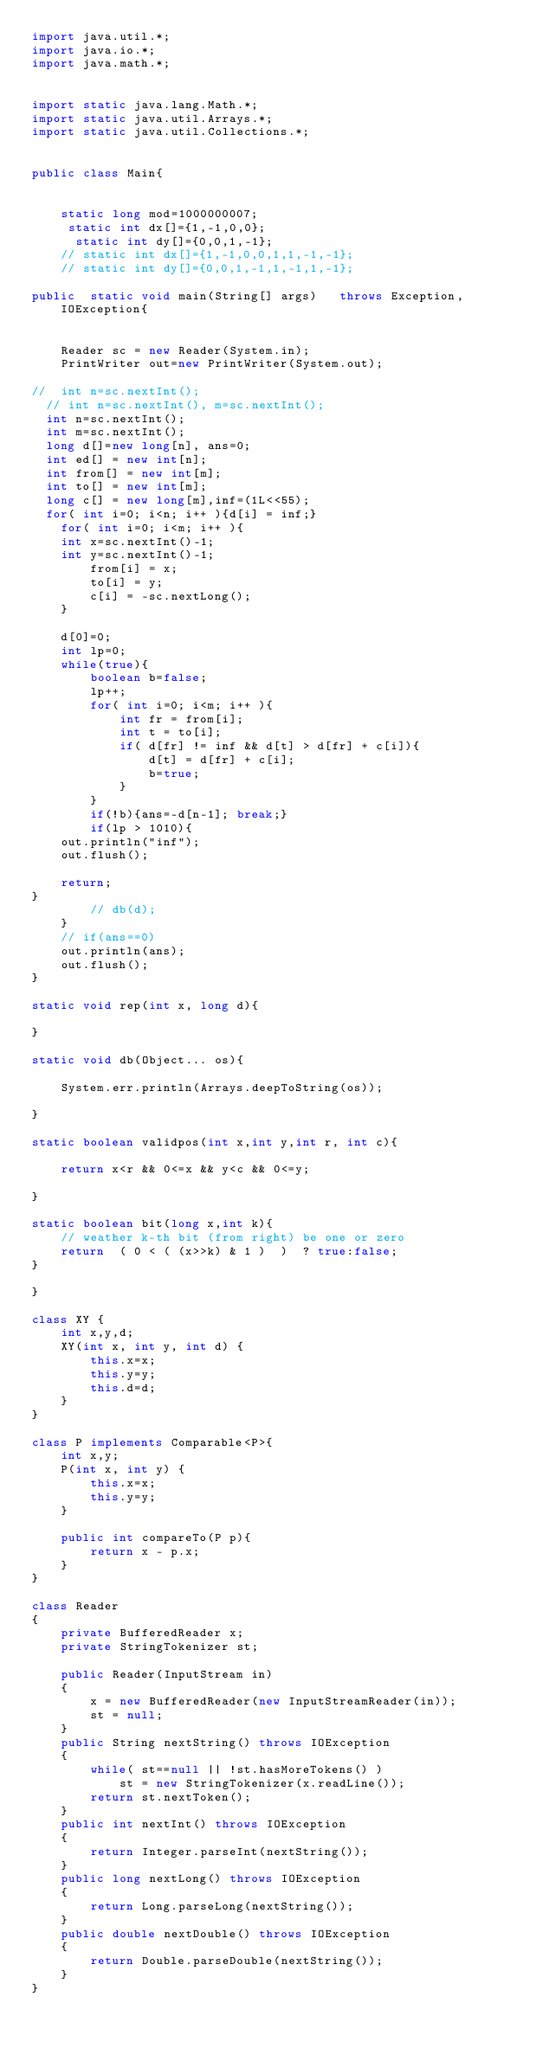Convert code to text. <code><loc_0><loc_0><loc_500><loc_500><_Java_>import java.util.*;
import java.io.*;
import java.math.*;


import static java.lang.Math.*;
import static java.util.Arrays.*;
import static java.util.Collections.*;


public class Main{ 


    static long mod=1000000007;
     static int dx[]={1,-1,0,0};
      static int dy[]={0,0,1,-1};
    // static int dx[]={1,-1,0,0,1,1,-1,-1};
    // static int dy[]={0,0,1,-1,1,-1,1,-1}; 

public  static void main(String[] args)   throws Exception, IOException{

    
    Reader sc = new Reader(System.in);
    PrintWriter out=new PrintWriter(System.out);

//  int n=sc.nextInt();  
  // int n=sc.nextInt(), m=sc.nextInt();  
  int n=sc.nextInt();  
  int m=sc.nextInt();  
  long d[]=new long[n], ans=0;
  int ed[] = new int[n];
  int from[] = new int[m];
  int to[] = new int[m];
  long c[] = new long[m],inf=(1L<<55);
  for( int i=0; i<n; i++ ){d[i] = inf;}
    for( int i=0; i<m; i++ ){
    int x=sc.nextInt()-1;
    int y=sc.nextInt()-1;
        from[i] = x;
        to[i] = y;
        c[i] = -sc.nextLong();
    }

    d[0]=0;
    int lp=0;
    while(true){
        boolean b=false;
        lp++;
        for( int i=0; i<m; i++ ){
            int fr = from[i];
            int t = to[i];
            if( d[fr] != inf && d[t] > d[fr] + c[i]){
                d[t] = d[fr] + c[i];
                b=true;
            }
        }
        if(!b){ans=-d[n-1]; break;}
        if(lp > 1010){
    out.println("inf");
    out.flush();

    return;
}
        // db(d);
    }
    // if(ans==0)
    out.println(ans);
    out.flush();
}

static void rep(int x, long d){

}

static void db(Object... os){

    System.err.println(Arrays.deepToString(os));

}

static boolean validpos(int x,int y,int r, int c){
    
    return x<r && 0<=x && y<c && 0<=y;
    
}
 
static boolean bit(long x,int k){
    // weather k-th bit (from right) be one or zero
    return  ( 0 < ( (x>>k) & 1 )  )  ? true:false;
}

}

class XY {
    int x,y,d;
    XY(int x, int y, int d) {
        this.x=x;
        this.y=y;
        this.d=d;
    } 
}

class P implements Comparable<P>{
    int x,y;
    P(int x, int y) {
        this.x=x;
        this.y=y;
    } 
      
    public int compareTo(P p){
        return x - p.x;
    } 
}

class Reader
{ 
    private BufferedReader x;
    private StringTokenizer st;
    
    public Reader(InputStream in)
    {
        x = new BufferedReader(new InputStreamReader(in));
        st = null;
    }
    public String nextString() throws IOException
    {
        while( st==null || !st.hasMoreTokens() )
            st = new StringTokenizer(x.readLine());
        return st.nextToken();
    }
    public int nextInt() throws IOException
    {
        return Integer.parseInt(nextString());
    }
    public long nextLong() throws IOException
    {
        return Long.parseLong(nextString());
    }
    public double nextDouble() throws IOException
    {
        return Double.parseDouble(nextString());
    }
}

</code> 